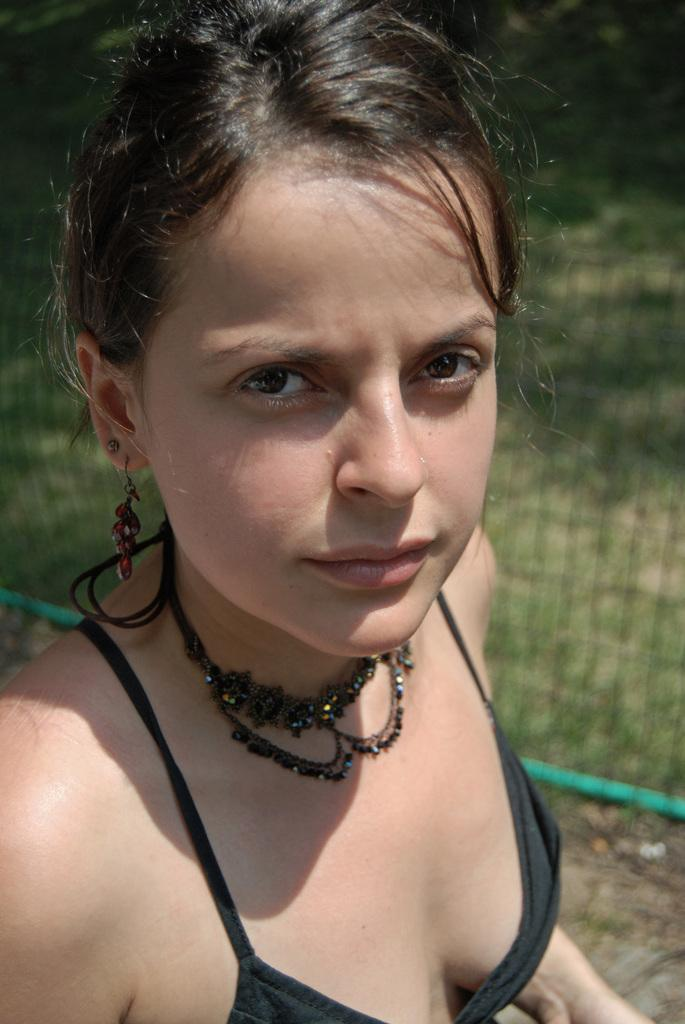What type of vegetation can be seen in the background of the image? There is green grass in the background of the image. What else is visible in the background of the image? There is a net in the background of the image. Who is present in the image? There is a woman in the image. What accessory is the woman wearing? The woman is wearing a necklace. What type of kettle is visible in the image? There is no kettle present in the image. What kind of furniture can be seen in the image? There is no furniture present in the image. 